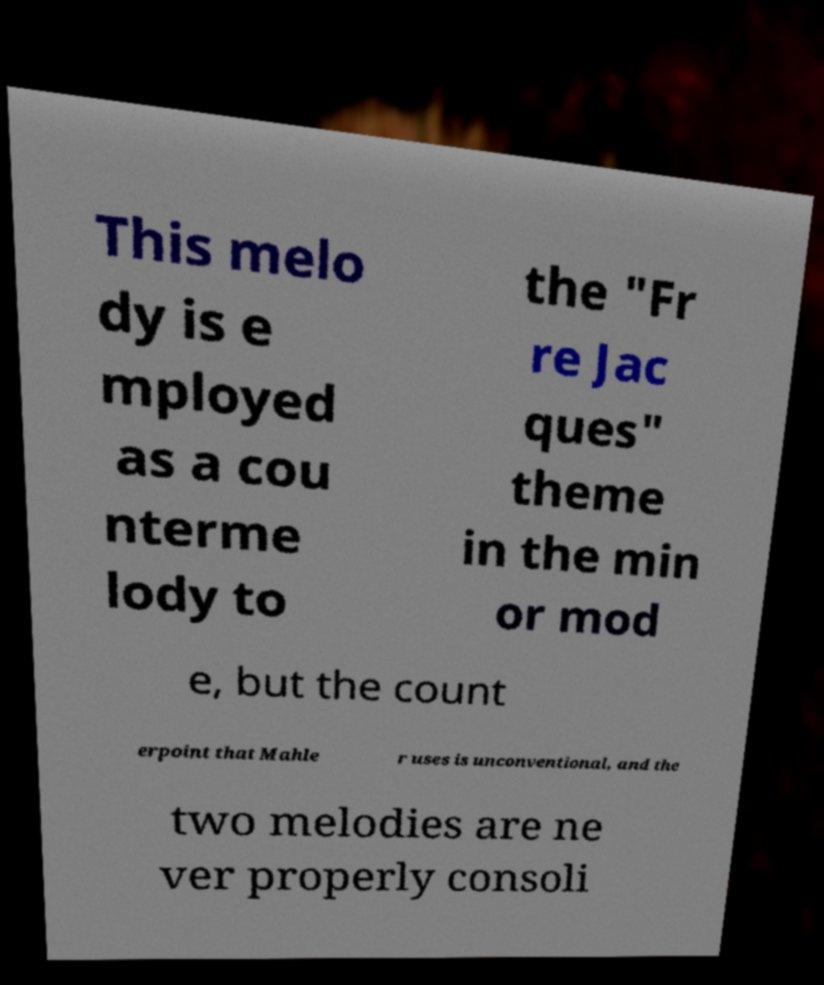Please read and relay the text visible in this image. What does it say? This melo dy is e mployed as a cou nterme lody to the "Fr re Jac ques" theme in the min or mod e, but the count erpoint that Mahle r uses is unconventional, and the two melodies are ne ver properly consoli 